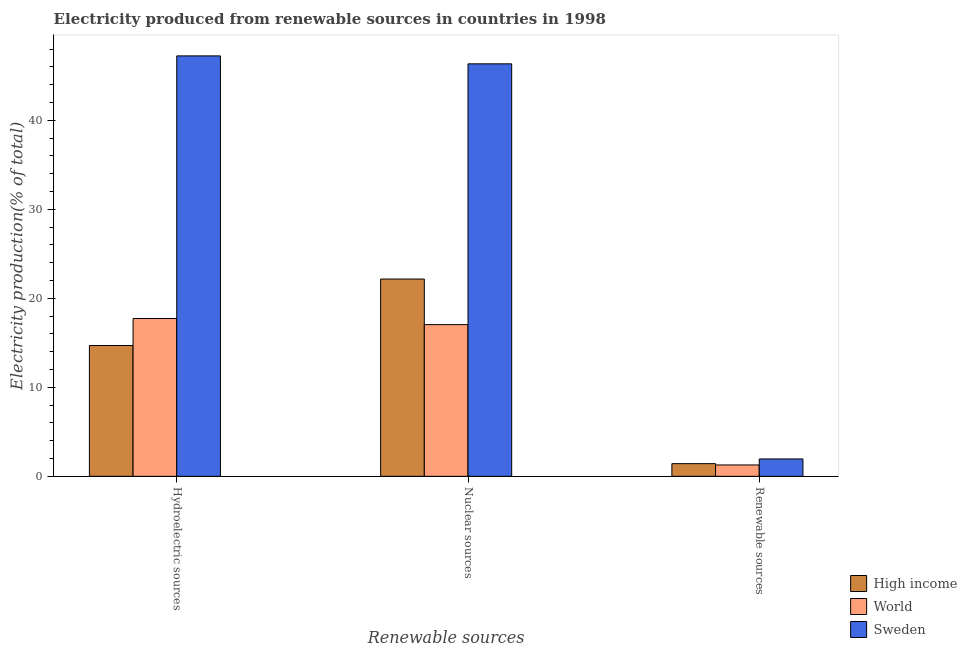How many groups of bars are there?
Make the answer very short. 3. Are the number of bars on each tick of the X-axis equal?
Your answer should be very brief. Yes. How many bars are there on the 3rd tick from the left?
Offer a terse response. 3. How many bars are there on the 1st tick from the right?
Your response must be concise. 3. What is the label of the 2nd group of bars from the left?
Offer a very short reply. Nuclear sources. What is the percentage of electricity produced by renewable sources in World?
Your response must be concise. 1.28. Across all countries, what is the maximum percentage of electricity produced by hydroelectric sources?
Provide a succinct answer. 47.23. Across all countries, what is the minimum percentage of electricity produced by nuclear sources?
Offer a terse response. 17.04. What is the total percentage of electricity produced by hydroelectric sources in the graph?
Make the answer very short. 79.66. What is the difference between the percentage of electricity produced by hydroelectric sources in Sweden and that in World?
Your response must be concise. 29.5. What is the difference between the percentage of electricity produced by hydroelectric sources in World and the percentage of electricity produced by nuclear sources in Sweden?
Offer a terse response. -28.61. What is the average percentage of electricity produced by hydroelectric sources per country?
Offer a very short reply. 26.55. What is the difference between the percentage of electricity produced by hydroelectric sources and percentage of electricity produced by renewable sources in High income?
Offer a terse response. 13.27. What is the ratio of the percentage of electricity produced by nuclear sources in Sweden to that in High income?
Your answer should be very brief. 2.09. What is the difference between the highest and the second highest percentage of electricity produced by nuclear sources?
Offer a terse response. 24.18. What is the difference between the highest and the lowest percentage of electricity produced by renewable sources?
Provide a short and direct response. 0.68. Is the sum of the percentage of electricity produced by hydroelectric sources in High income and Sweden greater than the maximum percentage of electricity produced by renewable sources across all countries?
Give a very brief answer. Yes. Is it the case that in every country, the sum of the percentage of electricity produced by hydroelectric sources and percentage of electricity produced by nuclear sources is greater than the percentage of electricity produced by renewable sources?
Offer a very short reply. Yes. How many bars are there?
Provide a short and direct response. 9. Are all the bars in the graph horizontal?
Make the answer very short. No. What is the difference between two consecutive major ticks on the Y-axis?
Provide a short and direct response. 10. Are the values on the major ticks of Y-axis written in scientific E-notation?
Your answer should be compact. No. Where does the legend appear in the graph?
Make the answer very short. Bottom right. How many legend labels are there?
Provide a succinct answer. 3. How are the legend labels stacked?
Provide a short and direct response. Vertical. What is the title of the graph?
Your answer should be very brief. Electricity produced from renewable sources in countries in 1998. Does "Togo" appear as one of the legend labels in the graph?
Give a very brief answer. No. What is the label or title of the X-axis?
Offer a very short reply. Renewable sources. What is the Electricity production(% of total) of High income in Hydroelectric sources?
Ensure brevity in your answer.  14.69. What is the Electricity production(% of total) in World in Hydroelectric sources?
Offer a very short reply. 17.73. What is the Electricity production(% of total) in Sweden in Hydroelectric sources?
Provide a succinct answer. 47.23. What is the Electricity production(% of total) in High income in Nuclear sources?
Your answer should be very brief. 22.16. What is the Electricity production(% of total) in World in Nuclear sources?
Your answer should be compact. 17.04. What is the Electricity production(% of total) of Sweden in Nuclear sources?
Offer a terse response. 46.34. What is the Electricity production(% of total) of High income in Renewable sources?
Offer a terse response. 1.42. What is the Electricity production(% of total) in World in Renewable sources?
Ensure brevity in your answer.  1.28. What is the Electricity production(% of total) in Sweden in Renewable sources?
Ensure brevity in your answer.  1.95. Across all Renewable sources, what is the maximum Electricity production(% of total) of High income?
Offer a terse response. 22.16. Across all Renewable sources, what is the maximum Electricity production(% of total) of World?
Provide a succinct answer. 17.73. Across all Renewable sources, what is the maximum Electricity production(% of total) in Sweden?
Your answer should be compact. 47.23. Across all Renewable sources, what is the minimum Electricity production(% of total) in High income?
Offer a terse response. 1.42. Across all Renewable sources, what is the minimum Electricity production(% of total) in World?
Offer a terse response. 1.28. Across all Renewable sources, what is the minimum Electricity production(% of total) of Sweden?
Ensure brevity in your answer.  1.95. What is the total Electricity production(% of total) in High income in the graph?
Your answer should be compact. 38.28. What is the total Electricity production(% of total) in World in the graph?
Offer a terse response. 36.05. What is the total Electricity production(% of total) of Sweden in the graph?
Your response must be concise. 95.52. What is the difference between the Electricity production(% of total) of High income in Hydroelectric sources and that in Nuclear sources?
Keep it short and to the point. -7.47. What is the difference between the Electricity production(% of total) of World in Hydroelectric sources and that in Nuclear sources?
Ensure brevity in your answer.  0.69. What is the difference between the Electricity production(% of total) of Sweden in Hydroelectric sources and that in Nuclear sources?
Ensure brevity in your answer.  0.89. What is the difference between the Electricity production(% of total) in High income in Hydroelectric sources and that in Renewable sources?
Your answer should be compact. 13.27. What is the difference between the Electricity production(% of total) of World in Hydroelectric sources and that in Renewable sources?
Provide a succinct answer. 16.45. What is the difference between the Electricity production(% of total) in Sweden in Hydroelectric sources and that in Renewable sources?
Provide a succinct answer. 45.28. What is the difference between the Electricity production(% of total) in High income in Nuclear sources and that in Renewable sources?
Offer a very short reply. 20.74. What is the difference between the Electricity production(% of total) in World in Nuclear sources and that in Renewable sources?
Your response must be concise. 15.77. What is the difference between the Electricity production(% of total) of Sweden in Nuclear sources and that in Renewable sources?
Offer a terse response. 44.39. What is the difference between the Electricity production(% of total) in High income in Hydroelectric sources and the Electricity production(% of total) in World in Nuclear sources?
Provide a succinct answer. -2.35. What is the difference between the Electricity production(% of total) of High income in Hydroelectric sources and the Electricity production(% of total) of Sweden in Nuclear sources?
Your answer should be very brief. -31.64. What is the difference between the Electricity production(% of total) of World in Hydroelectric sources and the Electricity production(% of total) of Sweden in Nuclear sources?
Keep it short and to the point. -28.61. What is the difference between the Electricity production(% of total) of High income in Hydroelectric sources and the Electricity production(% of total) of World in Renewable sources?
Offer a terse response. 13.42. What is the difference between the Electricity production(% of total) of High income in Hydroelectric sources and the Electricity production(% of total) of Sweden in Renewable sources?
Your response must be concise. 12.74. What is the difference between the Electricity production(% of total) in World in Hydroelectric sources and the Electricity production(% of total) in Sweden in Renewable sources?
Your response must be concise. 15.78. What is the difference between the Electricity production(% of total) in High income in Nuclear sources and the Electricity production(% of total) in World in Renewable sources?
Your answer should be very brief. 20.89. What is the difference between the Electricity production(% of total) of High income in Nuclear sources and the Electricity production(% of total) of Sweden in Renewable sources?
Your response must be concise. 20.21. What is the difference between the Electricity production(% of total) in World in Nuclear sources and the Electricity production(% of total) in Sweden in Renewable sources?
Offer a terse response. 15.09. What is the average Electricity production(% of total) in High income per Renewable sources?
Give a very brief answer. 12.76. What is the average Electricity production(% of total) in World per Renewable sources?
Keep it short and to the point. 12.02. What is the average Electricity production(% of total) of Sweden per Renewable sources?
Your answer should be very brief. 31.84. What is the difference between the Electricity production(% of total) of High income and Electricity production(% of total) of World in Hydroelectric sources?
Ensure brevity in your answer.  -3.03. What is the difference between the Electricity production(% of total) of High income and Electricity production(% of total) of Sweden in Hydroelectric sources?
Your response must be concise. -32.54. What is the difference between the Electricity production(% of total) in World and Electricity production(% of total) in Sweden in Hydroelectric sources?
Make the answer very short. -29.5. What is the difference between the Electricity production(% of total) of High income and Electricity production(% of total) of World in Nuclear sources?
Your response must be concise. 5.12. What is the difference between the Electricity production(% of total) in High income and Electricity production(% of total) in Sweden in Nuclear sources?
Offer a very short reply. -24.18. What is the difference between the Electricity production(% of total) in World and Electricity production(% of total) in Sweden in Nuclear sources?
Keep it short and to the point. -29.3. What is the difference between the Electricity production(% of total) of High income and Electricity production(% of total) of World in Renewable sources?
Your answer should be compact. 0.15. What is the difference between the Electricity production(% of total) of High income and Electricity production(% of total) of Sweden in Renewable sources?
Provide a short and direct response. -0.53. What is the difference between the Electricity production(% of total) in World and Electricity production(% of total) in Sweden in Renewable sources?
Offer a terse response. -0.68. What is the ratio of the Electricity production(% of total) in High income in Hydroelectric sources to that in Nuclear sources?
Keep it short and to the point. 0.66. What is the ratio of the Electricity production(% of total) in World in Hydroelectric sources to that in Nuclear sources?
Provide a short and direct response. 1.04. What is the ratio of the Electricity production(% of total) of Sweden in Hydroelectric sources to that in Nuclear sources?
Your answer should be compact. 1.02. What is the ratio of the Electricity production(% of total) of High income in Hydroelectric sources to that in Renewable sources?
Provide a short and direct response. 10.33. What is the ratio of the Electricity production(% of total) in World in Hydroelectric sources to that in Renewable sources?
Provide a succinct answer. 13.9. What is the ratio of the Electricity production(% of total) of Sweden in Hydroelectric sources to that in Renewable sources?
Provide a short and direct response. 24.21. What is the ratio of the Electricity production(% of total) in High income in Nuclear sources to that in Renewable sources?
Provide a succinct answer. 15.58. What is the ratio of the Electricity production(% of total) in World in Nuclear sources to that in Renewable sources?
Make the answer very short. 13.37. What is the ratio of the Electricity production(% of total) of Sweden in Nuclear sources to that in Renewable sources?
Your answer should be compact. 23.75. What is the difference between the highest and the second highest Electricity production(% of total) of High income?
Give a very brief answer. 7.47. What is the difference between the highest and the second highest Electricity production(% of total) in World?
Offer a very short reply. 0.69. What is the difference between the highest and the second highest Electricity production(% of total) in Sweden?
Ensure brevity in your answer.  0.89. What is the difference between the highest and the lowest Electricity production(% of total) in High income?
Offer a terse response. 20.74. What is the difference between the highest and the lowest Electricity production(% of total) of World?
Give a very brief answer. 16.45. What is the difference between the highest and the lowest Electricity production(% of total) of Sweden?
Keep it short and to the point. 45.28. 